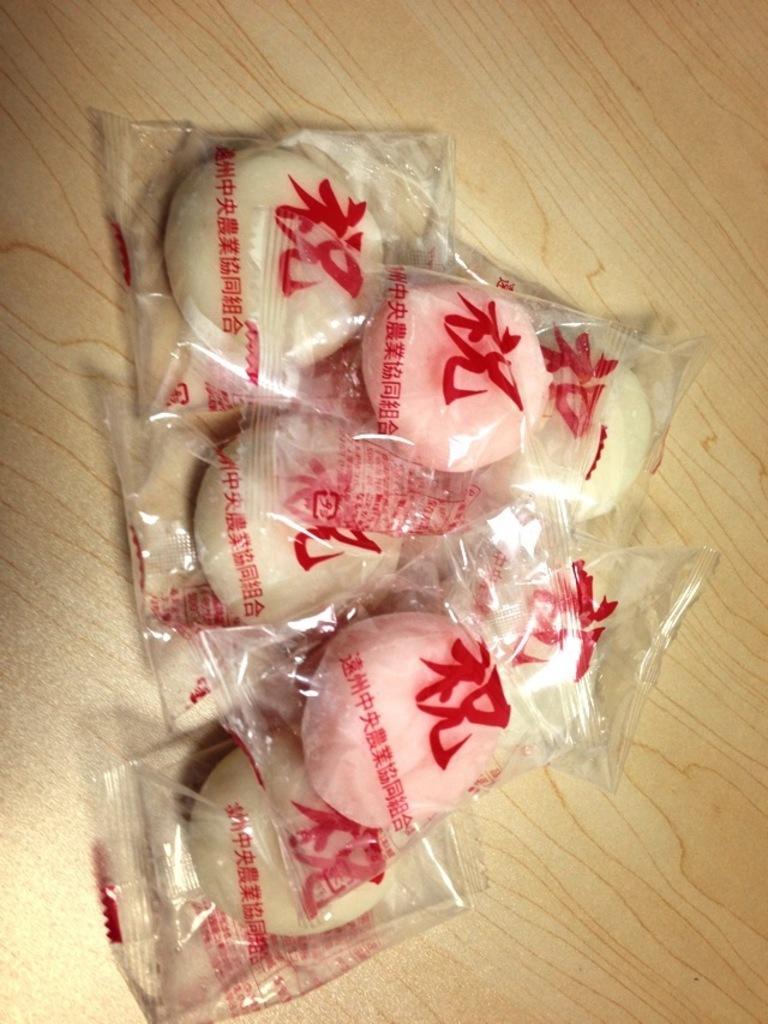How would you summarize this image in a sentence or two? In this image I can see few cream and pink color objects covered in the plastic cover. They are on the brown surface. 